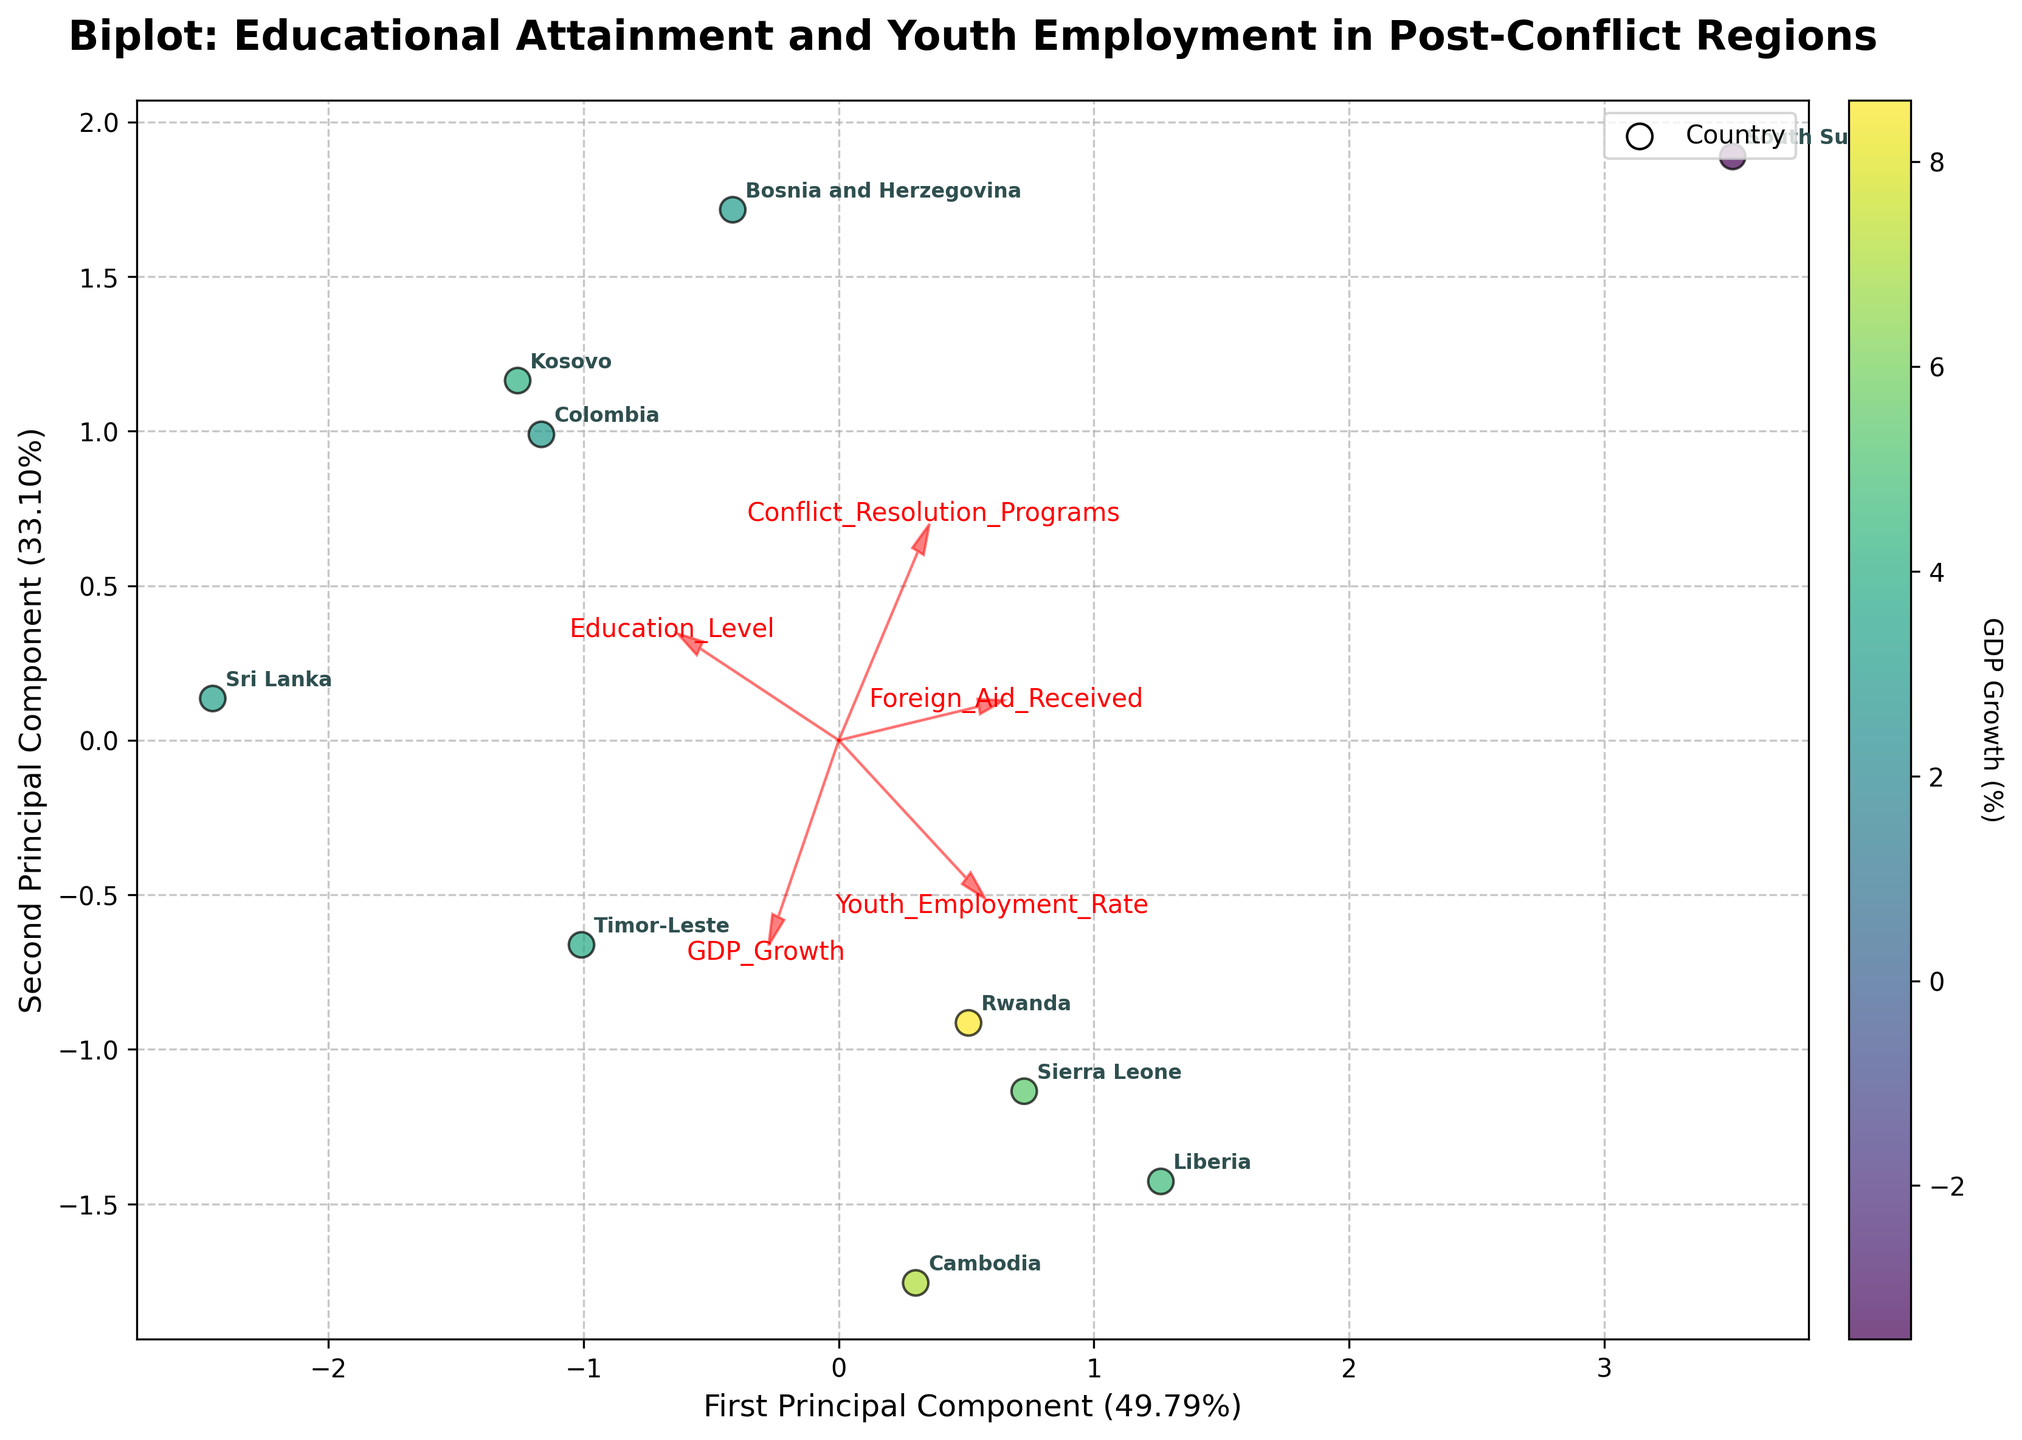What is the title of the plot? The title is located at the top of the plot. It helps to understand the subject of the graph.
Answer: Biplot: Educational Attainment and Youth Employment in Post-Conflict Regions How many data points are plotted in the figure? Each data point represents a country and is marked with a label and a scatter symbol. Counting these markers will give the total number of data points.
Answer: 10 Which country has the highest youth employment rate? The youth employment rate is visually represented on one of the axes. Locate the data point that corresponds to the highest value on that axis.
Answer: Liberia Which principal component explains the majority of the variance in the data? The labels of the axes give the percentages of variance explained by the principal components. Identify which axis has the higher percentage.
Answer: First Principal Component Which feature vector (red arrows) has the greatest influence on the first principal component? Look at the red arrows. The longest arrow along the direction of the first principal component indicates which feature has the greatest influence.
Answer: Education_Level Compare the GDP Growth between Rwanda and South Sudan. Which country has a higher value? The color map represents the GDP Growth. Identify the colors of Rwanda and South Sudan, and compare their positions in the color scale with the color bar.
Answer: Rwanda What percentage of variance is explained by the second principal component? Check the axis label for the second principal component. It will indicate the percentage of variance explained.
Answer: 27.62% How does Timor-Leste's position relate to its youth employment rate and educational level? Examine the position of Timor-Leste on both principal components and the direction of the vectors for youth employment rate and educational level. Reason out if Timor-Leste is higher or lower on these scales from its position relative to the origin and the arrows.
Answer: Moderate educational level, low youth employment rate How do conflict resolution programs influence the position of Colombia on the biplot? Look at the vector direction for "Conflict_Resolution_Programs" and the position of Colombia in relation to this vector to see if Colombia is positively or negatively influenced.
Answer: Positively influenced What relationship can you infer between foreign aid received and GDP growth from the biplot? Analyze the vectors for "Foreign_Aid_Received" and "GDP_Growth." Look at their directions and how data points align with these vectors to infer if higher foreign aid is linked with higher or lower GDP growth.
Answer: Positive correlation 